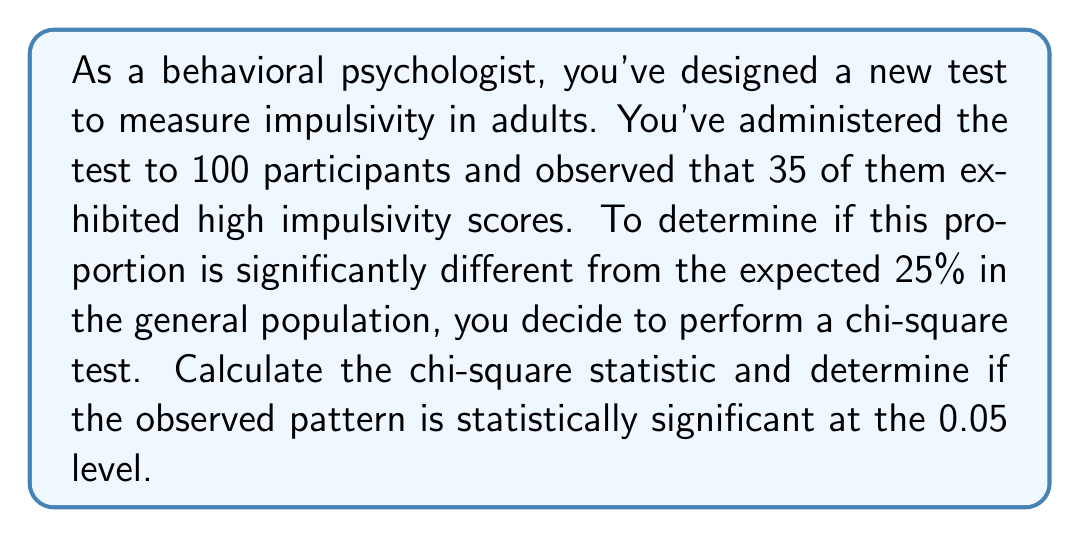Give your solution to this math problem. To solve this problem, we'll follow these steps:

1. Set up the null and alternative hypotheses:
   $H_0$: The proportion of high impulsivity scores is 25% (same as the general population)
   $H_a$: The proportion of high impulsivity scores is different from 25%

2. Calculate the expected frequencies:
   Expected high impulsivity: $100 \times 0.25 = 25$
   Expected low impulsivity: $100 \times 0.75 = 75$

3. Calculate the chi-square statistic using the formula:
   $$\chi^2 = \sum \frac{(O - E)^2}{E}$$
   Where $O$ is the observed frequency and $E$ is the expected frequency.

   For high impulsivity:
   $$\frac{(35 - 25)^2}{25} = \frac{100}{25} = 4$$

   For low impulsivity:
   $$\frac{(65 - 75)^2}{75} = \frac{100}{75} = \frac{4}{3}$$

4. Sum the chi-square values:
   $$\chi^2 = 4 + \frac{4}{3} = \frac{16}{3} \approx 5.33$$

5. Determine the degrees of freedom (df):
   df = number of categories - 1 = 2 - 1 = 1

6. Compare the calculated chi-square value to the critical value:
   For df = 1 and α = 0.05, the critical value is 3.841.

   Since $5.33 > 3.841$, we reject the null hypothesis.
Answer: The chi-square statistic is $\chi^2 = \frac{16}{3} \approx 5.33$. This value is greater than the critical value of 3.841 for df = 1 and α = 0.05, so we conclude that the observed behavioral pattern is statistically significant at the 0.05 level. 